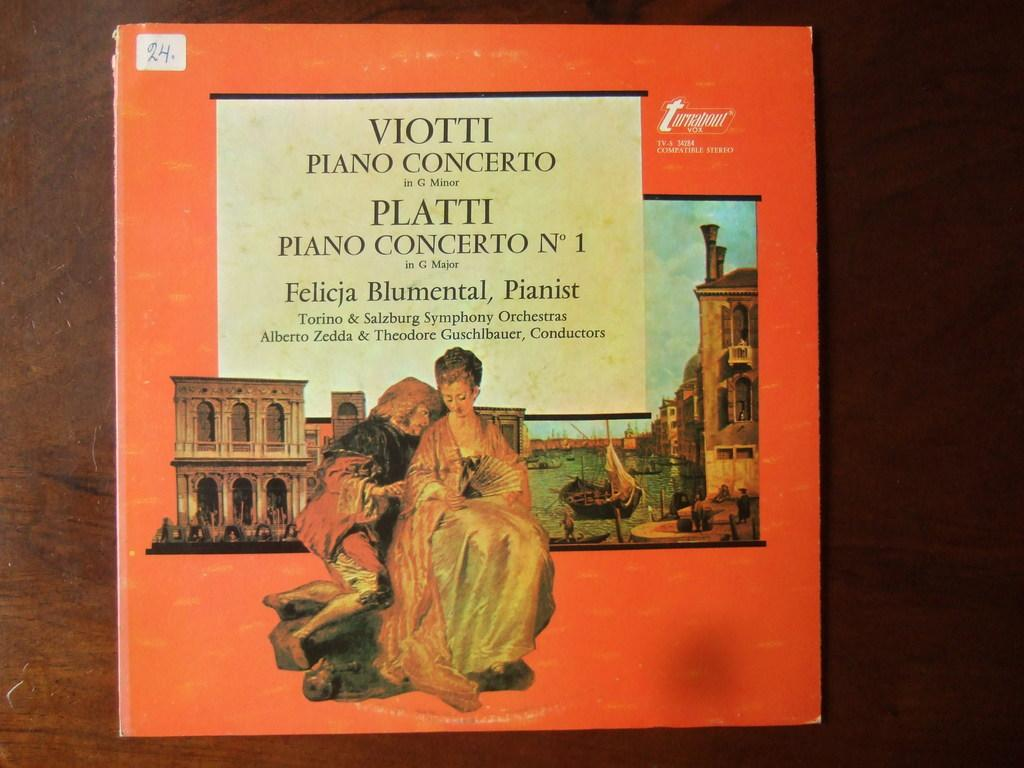Provide a one-sentence caption for the provided image. The record jacket describes two piano concertos, Viotti and Platti. 